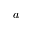Convert formula to latex. <formula><loc_0><loc_0><loc_500><loc_500>a</formula> 